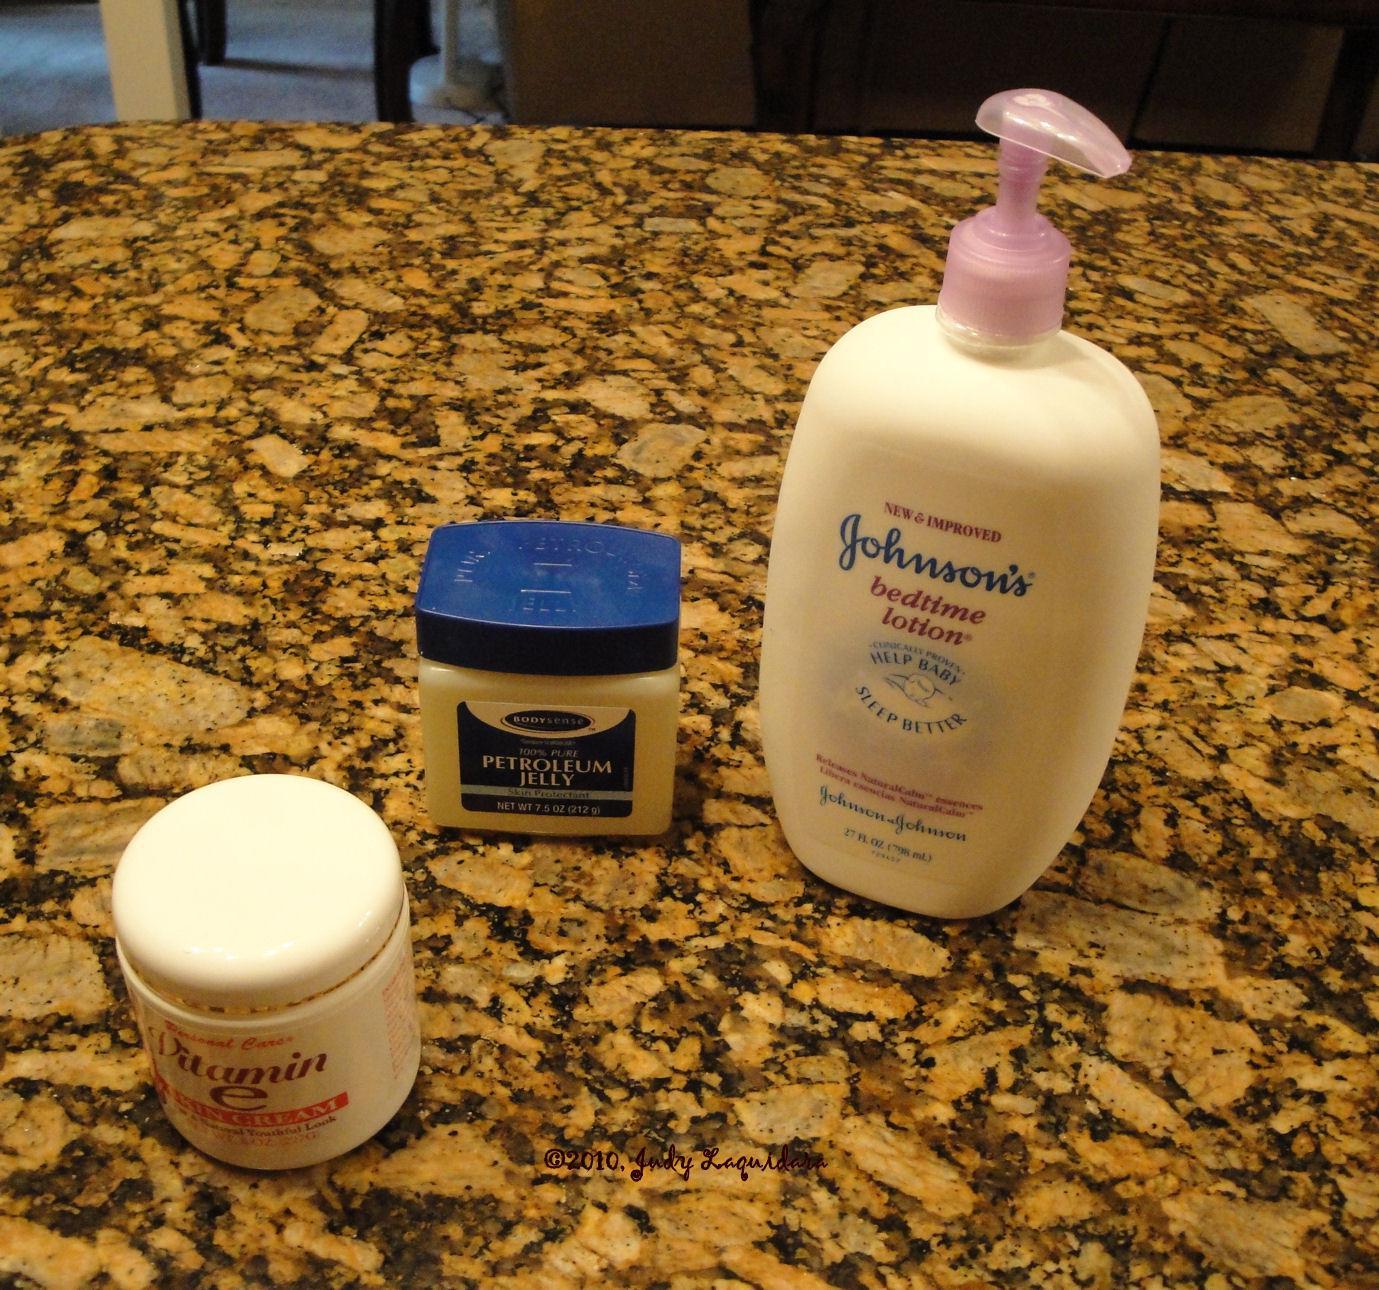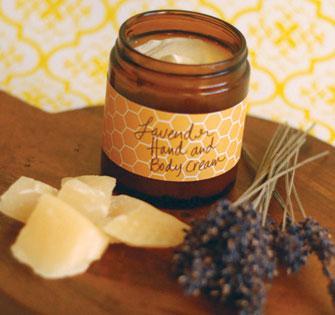The first image is the image on the left, the second image is the image on the right. Considering the images on both sides, is "An image includes an unlidded glass jar containing a pale creamy substance." valid? Answer yes or no. Yes. The first image is the image on the left, the second image is the image on the right. For the images shown, is this caption "A pump bottle of lotion is in one image with two other labeled products, while the second image shows an open jar of body cream among other items." true? Answer yes or no. Yes. 